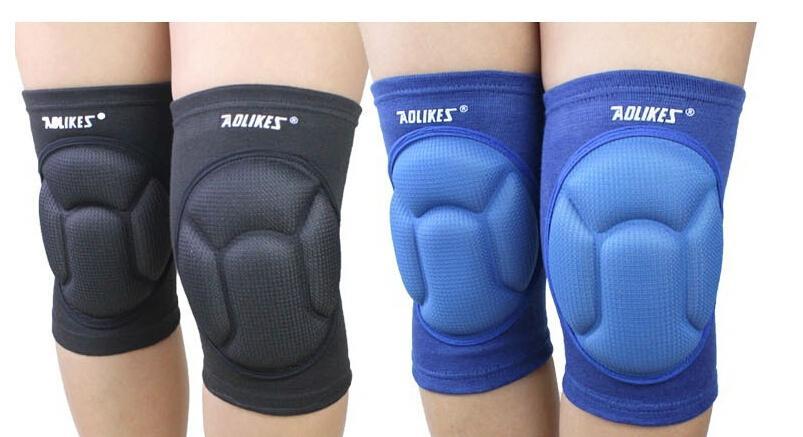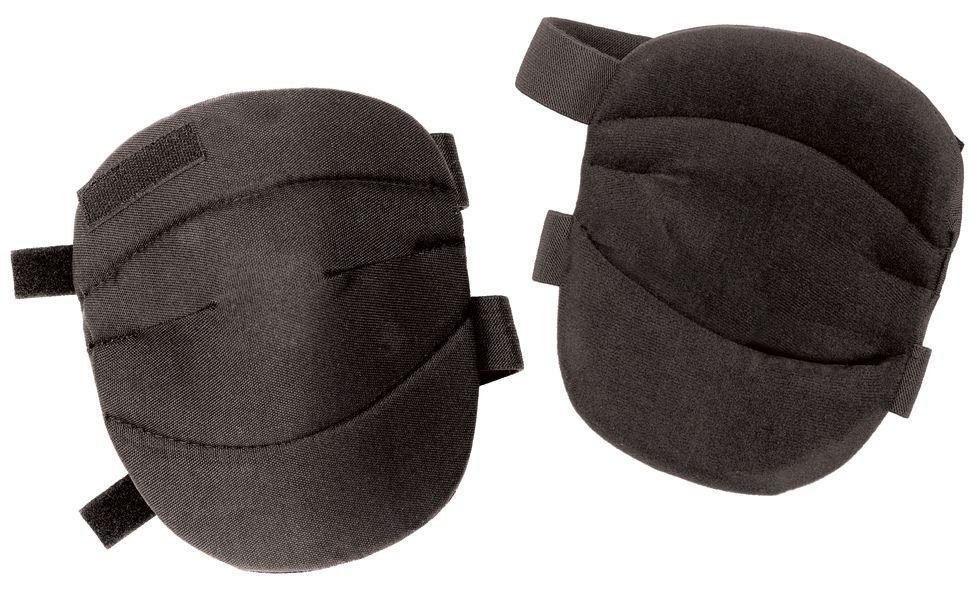The first image is the image on the left, the second image is the image on the right. Analyze the images presented: Is the assertion "The left image shows at least one pair of knee caps that are being worn on a person's legs" valid? Answer yes or no. Yes. The first image is the image on the left, the second image is the image on the right. Evaluate the accuracy of this statement regarding the images: "An image includes a pair of human legs wearing black knee-pads.". Is it true? Answer yes or no. Yes. 